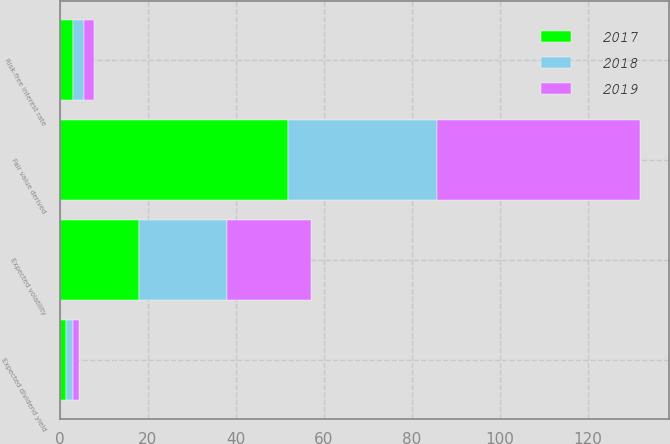<chart> <loc_0><loc_0><loc_500><loc_500><stacked_bar_chart><ecel><fcel>Risk-free interest rate<fcel>Expected volatility<fcel>Expected dividend yield<fcel>Fair value derived<nl><fcel>2017<fcel>3.05<fcel>18<fcel>1.27<fcel>51.86<nl><fcel>2019<fcel>2.32<fcel>19<fcel>1.33<fcel>46.1<nl><fcel>2018<fcel>2.33<fcel>20<fcel>1.71<fcel>33.81<nl></chart> 